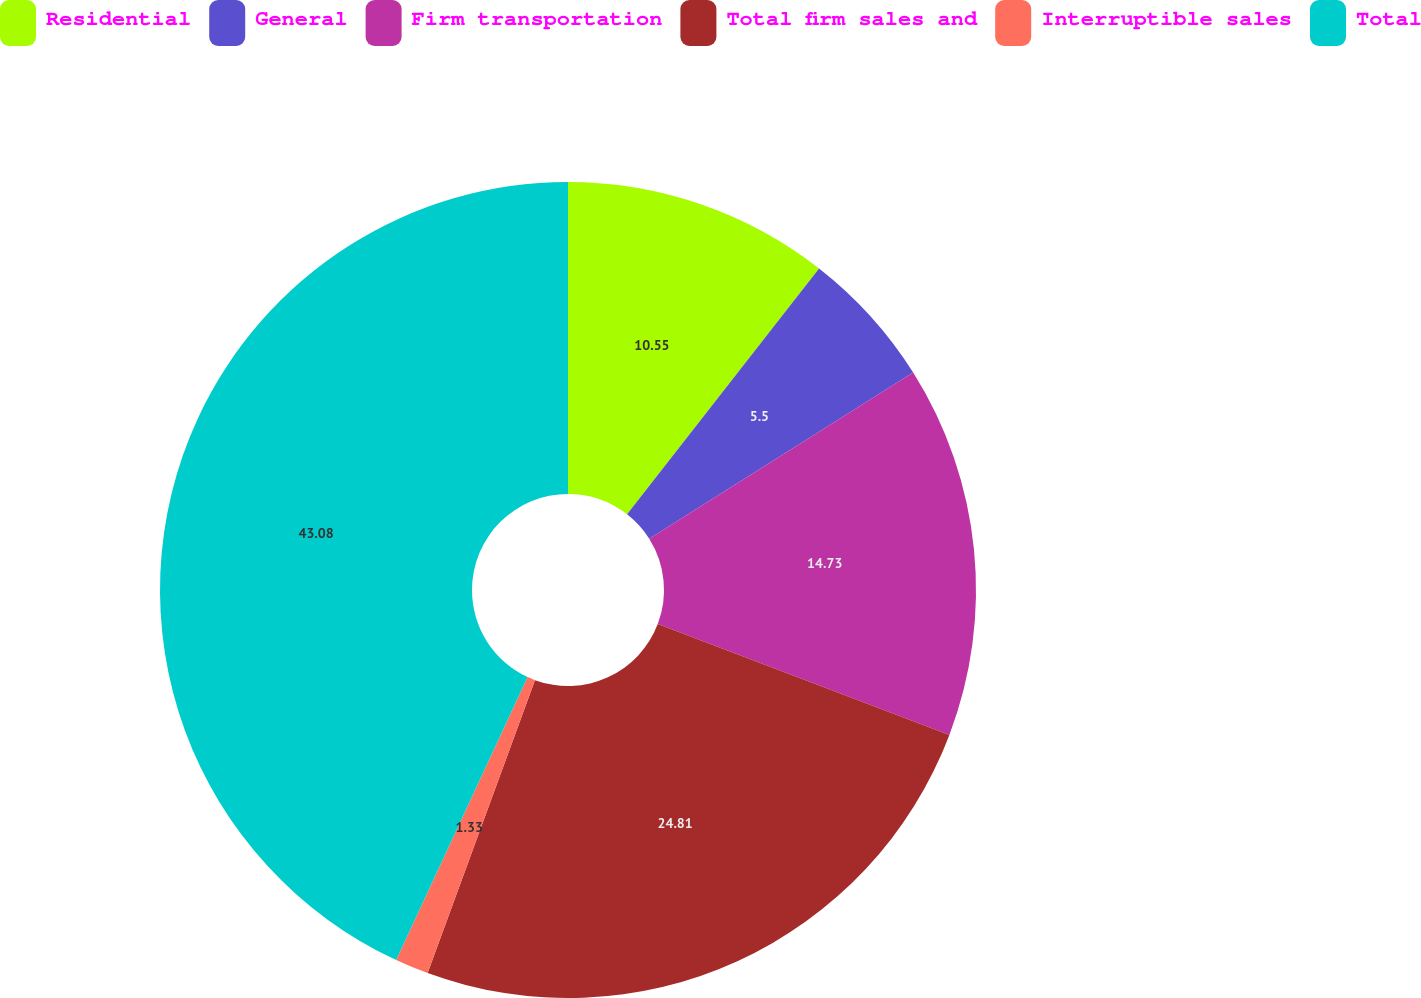Convert chart. <chart><loc_0><loc_0><loc_500><loc_500><pie_chart><fcel>Residential<fcel>General<fcel>Firm transportation<fcel>Total firm sales and<fcel>Interruptible sales<fcel>Total<nl><fcel>10.55%<fcel>5.5%<fcel>14.73%<fcel>24.81%<fcel>1.33%<fcel>43.08%<nl></chart> 